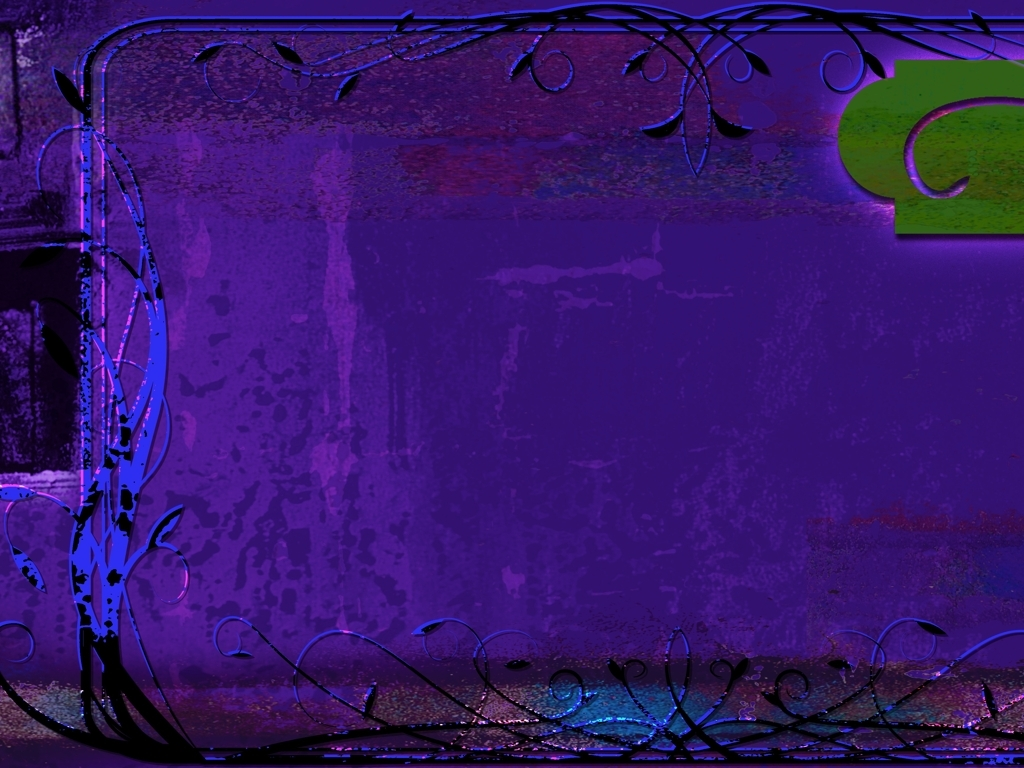Can you describe the elements in this picture that make it feel like it is from a fantasy? Certainly. The swirling, vine-like lines and abstract patterns contribute to the fantasy feel. They resemble tendrils or magical energy paths that you might expect to find in an enchanted forest or other fantastical setting. The blend of these intricate lines with the surreal color scheme enhances the notion that this image is from a realm beyond the ordinary. 